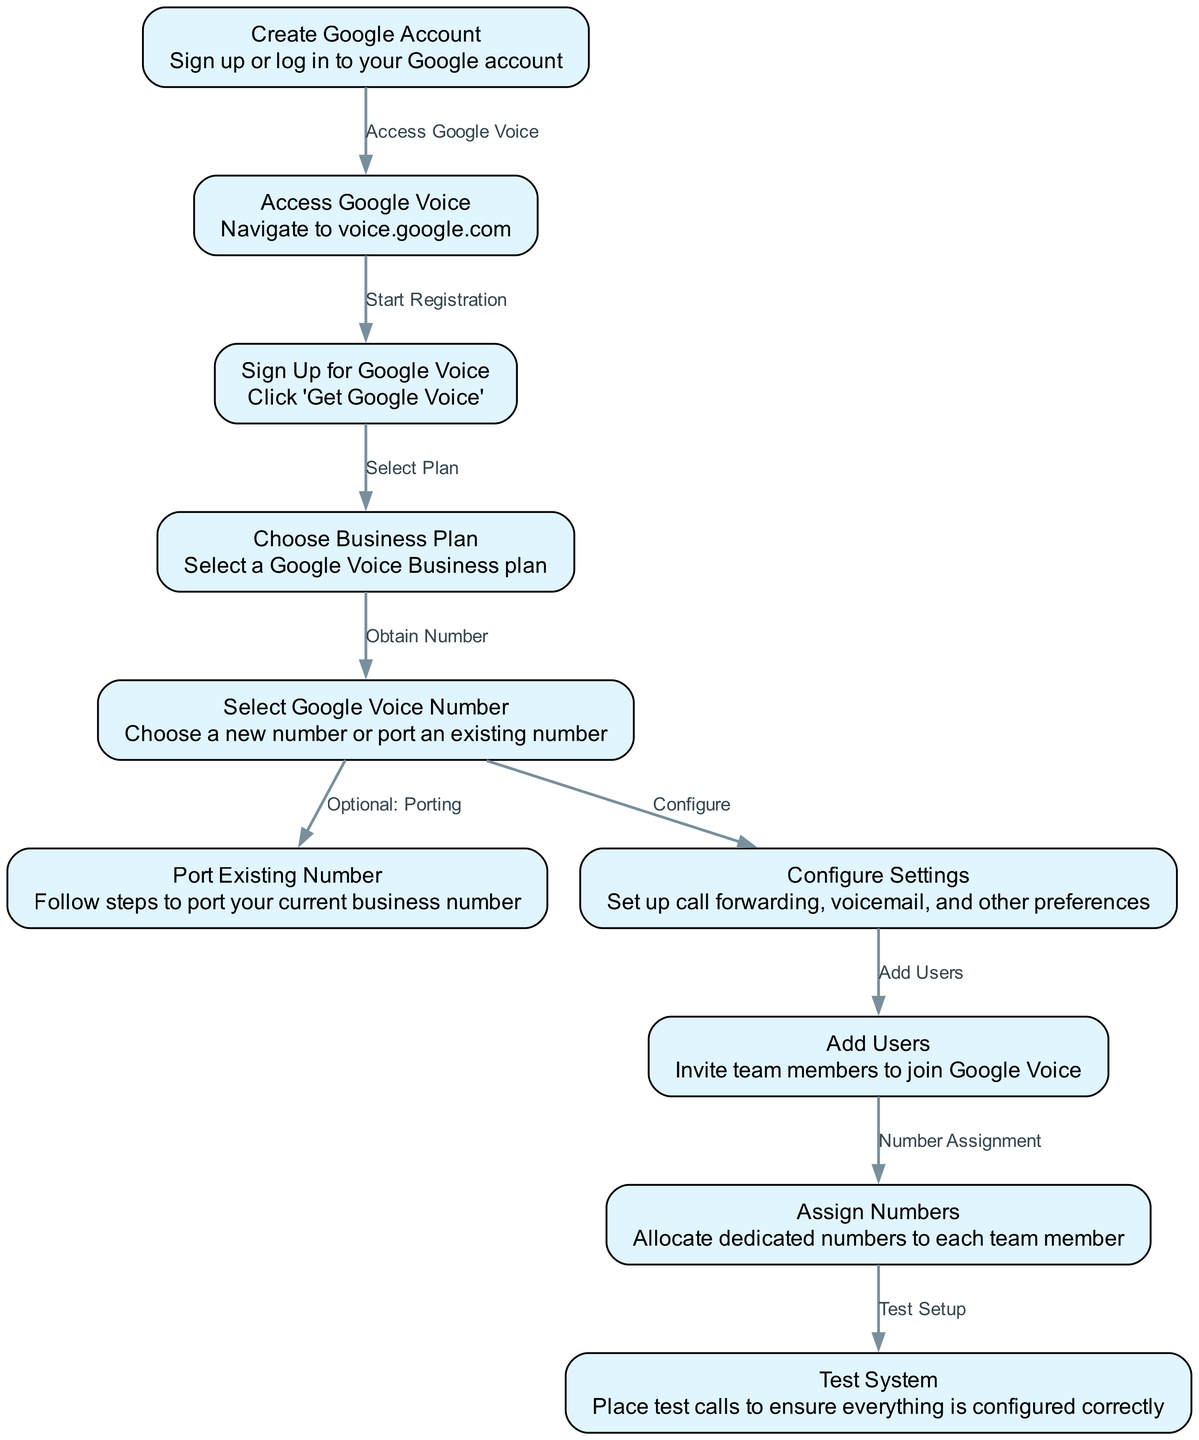What is the first step to set up Google Voice? The first step in the diagram is "Create Google Account," where you sign up or log in to your Google account.
Answer: Create Google Account How many nodes are in the diagram? By counting, there are ten nodes representing different steps in the setup process for Google Voice.
Answer: 10 What does the edge from 'Sign Up for Google Voice' to 'Choose Business Plan' represent? The edge indicates that after signing up for Google Voice, the next step is to select a business plan.
Answer: Select Plan What action follows after configuring settings? After configuring settings, the next action is to add users to the Google Voice account, as shown by the edge connecting these two steps.
Answer: Add Users What type of plan can you choose in the process? You can choose a 'Google Voice Business plan' during the setup as indicated by the node labeled "Choose Business Plan."
Answer: Business plan Which step involves potentially using an existing phone number? The step "Port Existing Number" is where you can follow steps to port your current business number into Google Voice.
Answer: Port Existing Number What is the last step outlined in the process? The last step in the diagram is "Test System," which involves placing test calls to ensure proper configuration.
Answer: Test System What comes before assigning numbers to users? Before assigning numbers to users, the step that comes right before it is "Add Users," where you invite team members to join Google Voice.
Answer: Add Users What relationship does the edge from 'Select Google Voice Number' to 'Port Existing Number' indicate? The edge indicates that after selecting a Google Voice number, porting an existing number is an optional action, linked by the label "Optional: Porting."
Answer: Optional: Porting 